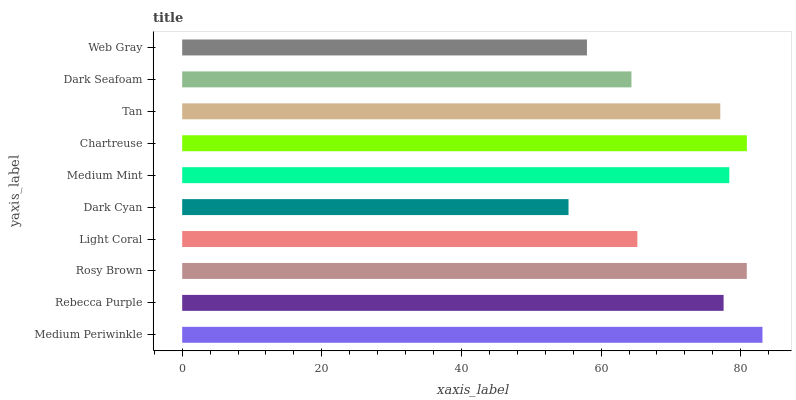Is Dark Cyan the minimum?
Answer yes or no. Yes. Is Medium Periwinkle the maximum?
Answer yes or no. Yes. Is Rebecca Purple the minimum?
Answer yes or no. No. Is Rebecca Purple the maximum?
Answer yes or no. No. Is Medium Periwinkle greater than Rebecca Purple?
Answer yes or no. Yes. Is Rebecca Purple less than Medium Periwinkle?
Answer yes or no. Yes. Is Rebecca Purple greater than Medium Periwinkle?
Answer yes or no. No. Is Medium Periwinkle less than Rebecca Purple?
Answer yes or no. No. Is Rebecca Purple the high median?
Answer yes or no. Yes. Is Tan the low median?
Answer yes or no. Yes. Is Rosy Brown the high median?
Answer yes or no. No. Is Medium Mint the low median?
Answer yes or no. No. 